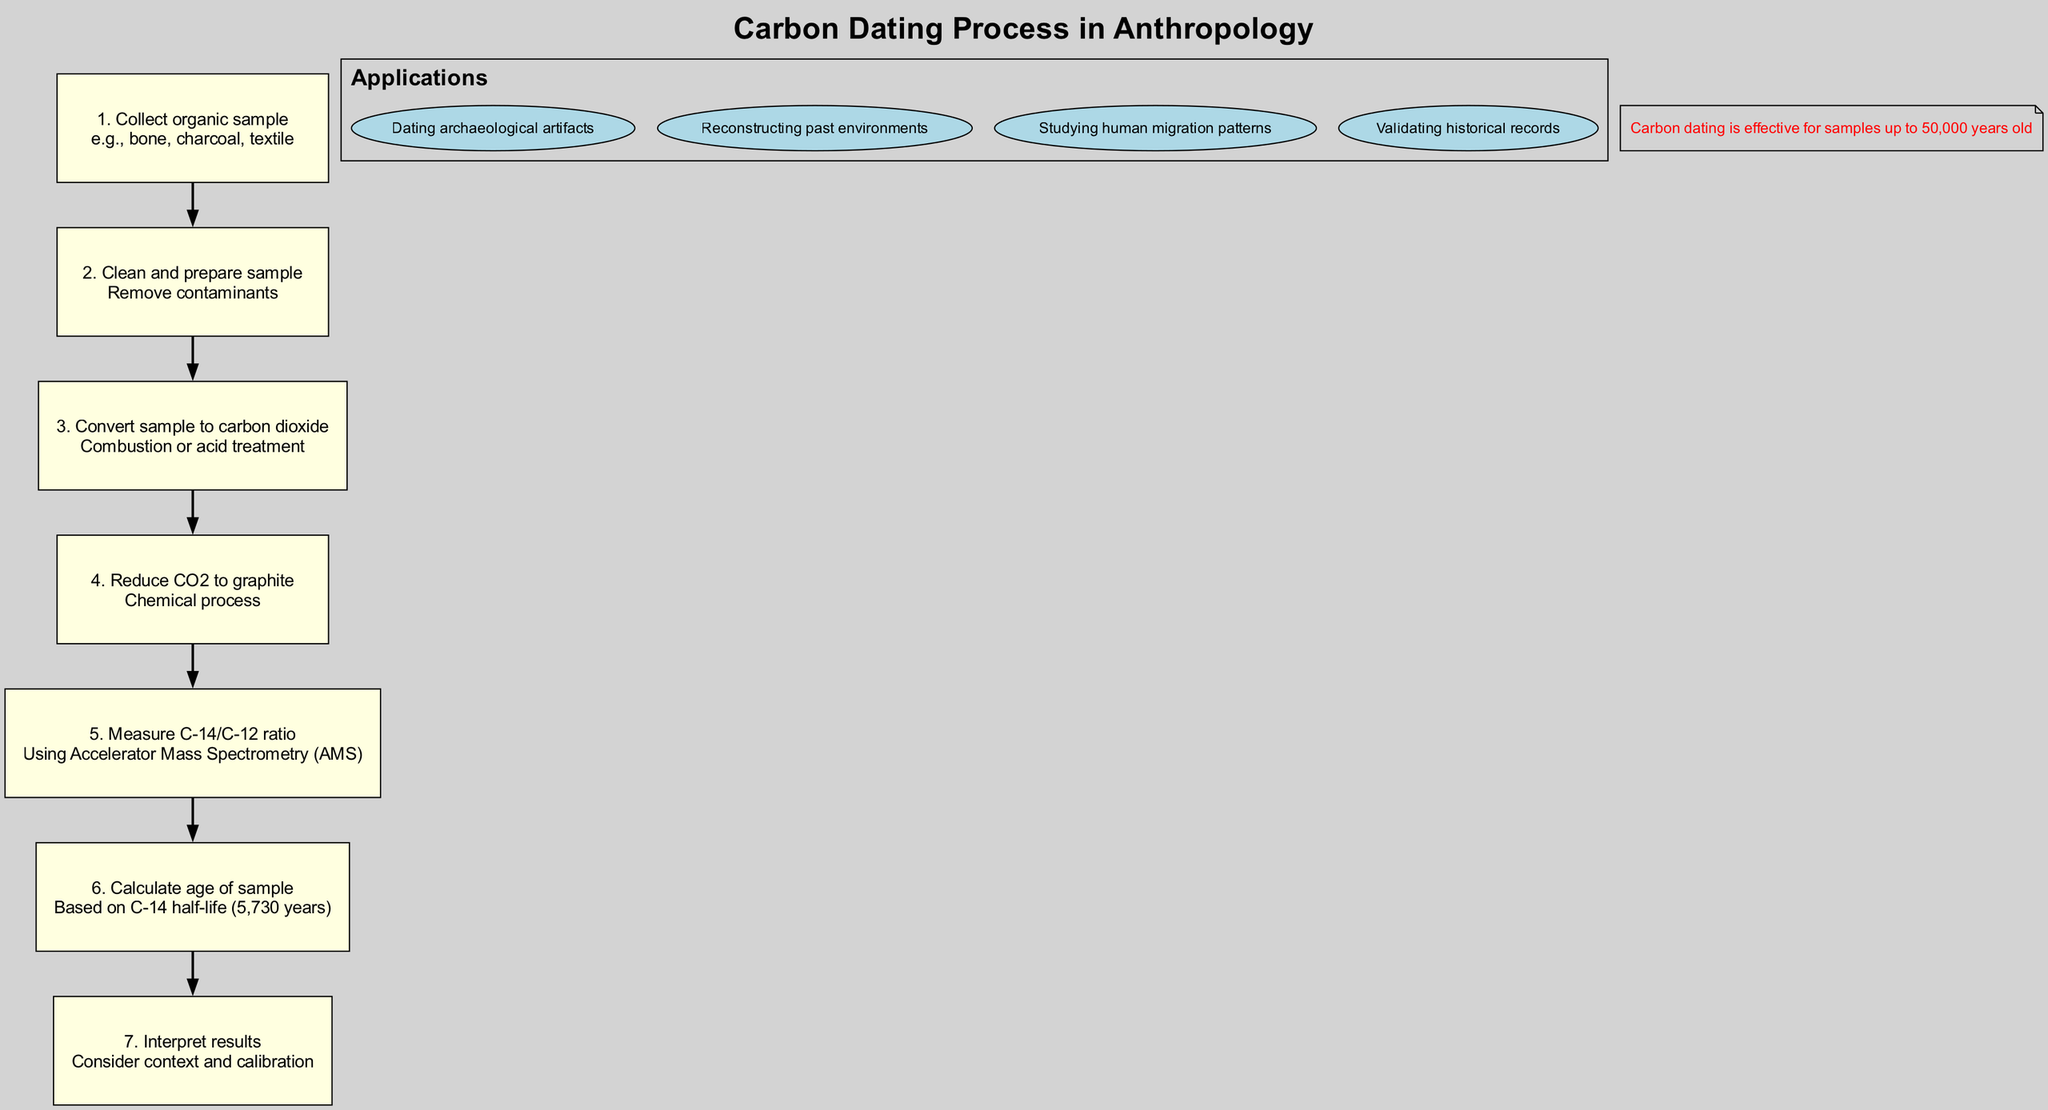What is the first step in the carbon dating process? The diagram lists the first step in the carbon dating process as "Collect organic sample." This is the title of the first node, indicating the beginning of the process flow.
Answer: Collect organic sample Which method is used to measure the C-14/C-12 ratio? According to step 5 in the diagram, the method used for measuring the C-14/C-12 ratio is "Accelerator Mass Spectrometry (AMS)." This is explicitly stated in the details of that node.
Answer: Accelerator Mass Spectrometry (AMS) How many total steps are involved in the carbon dating process? The diagram clearly lists a total of 7 steps involved in the carbon dating process. This can be counted directly from the steps section of the diagram.
Answer: 7 What is the carbon dating process effective for? The diagram mentions that carbon dating is effective for samples "up to 50,000 years old." This information is provided as a note at the bottom of the diagram.
Answer: 50,000 years old What step comes after converting the sample to carbon dioxide? The sequence of steps indicates that after converting the sample to carbon dioxide in step 3, the next step is to "Reduce CO2 to graphite." This is the text of step 4, showing the flow of the process.
Answer: Reduce CO2 to graphite In which step do researchers interpret results? The diagram specifies that the interpretation of results occurs in step 7. This is indicated by the text in that final node, which is focused on results interpretation.
Answer: Interpret results What is the significance of the C-14 half-life in the process? The C-14 half-life of 5,730 years is significant for calculating the age of samples. Step 6 indicates that the age calculation is based on this half-life, showing its relevance in the dating process.
Answer: 5,730 years Which applications are listed for carbon dating? The applications listed in the diagram include four specific areas like "Dating archaeological artifacts," "Reconstructing past environments," "Studying human migration patterns," and "Validating historical records." This can be found in the applications section of the diagram.
Answer: Dating archaeological artifacts, Reconstructing past environments, Studying human migration patterns, Validating historical records 